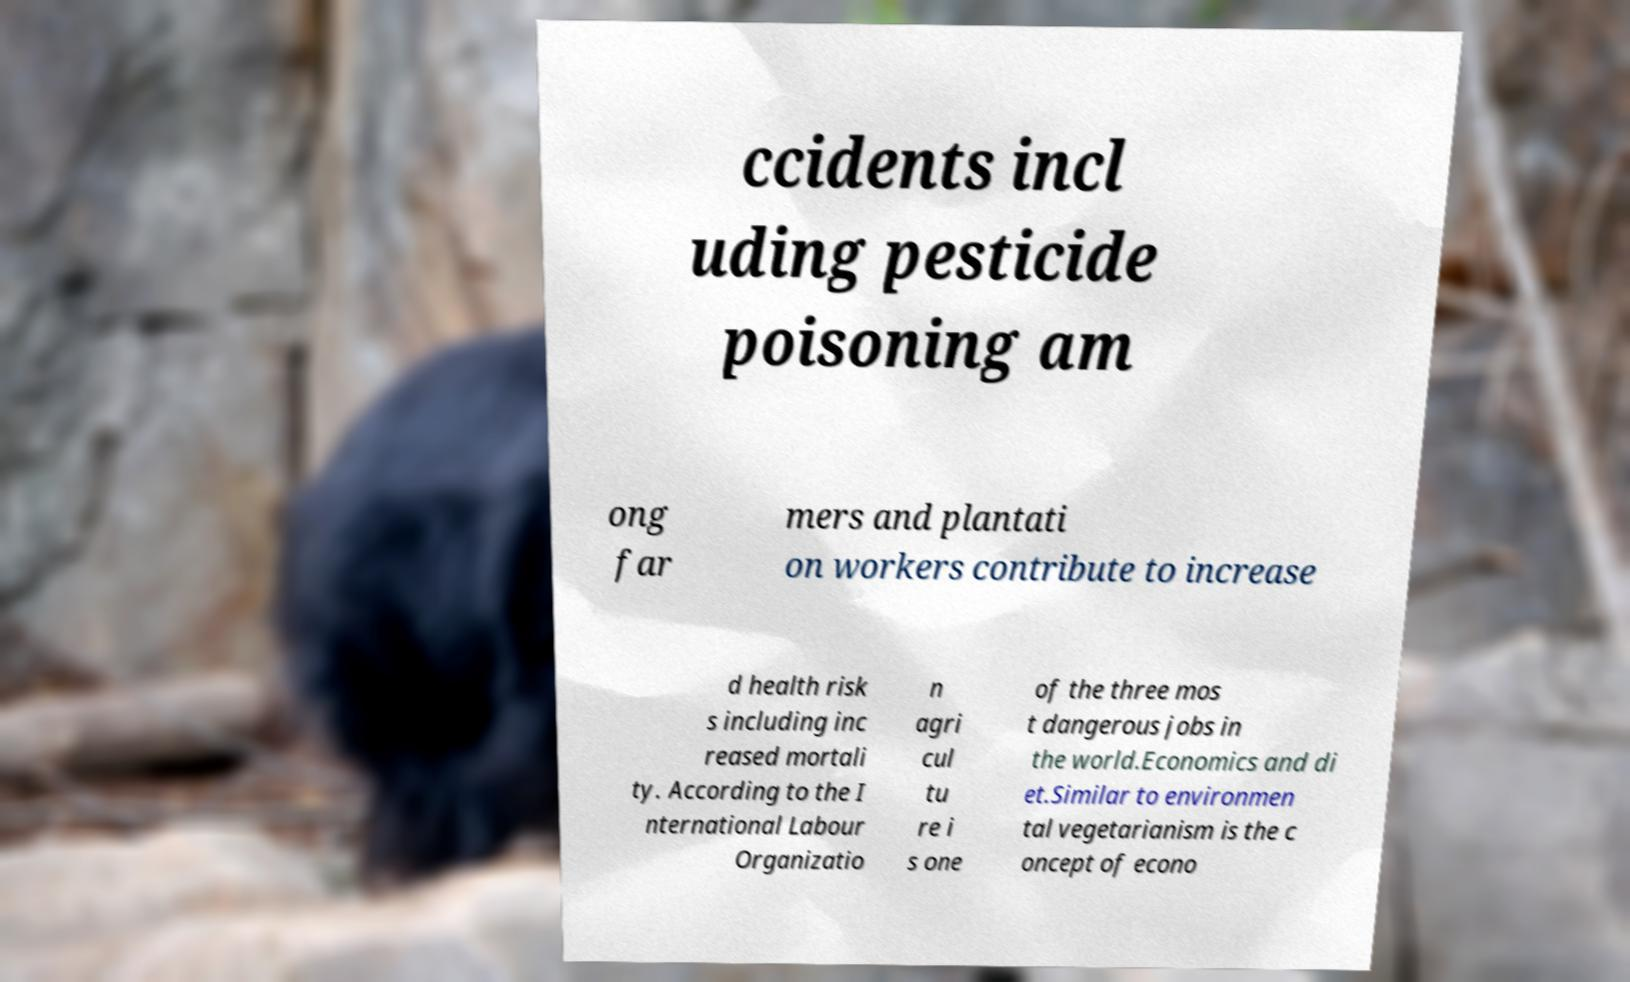Could you extract and type out the text from this image? ccidents incl uding pesticide poisoning am ong far mers and plantati on workers contribute to increase d health risk s including inc reased mortali ty. According to the I nternational Labour Organizatio n agri cul tu re i s one of the three mos t dangerous jobs in the world.Economics and di et.Similar to environmen tal vegetarianism is the c oncept of econo 